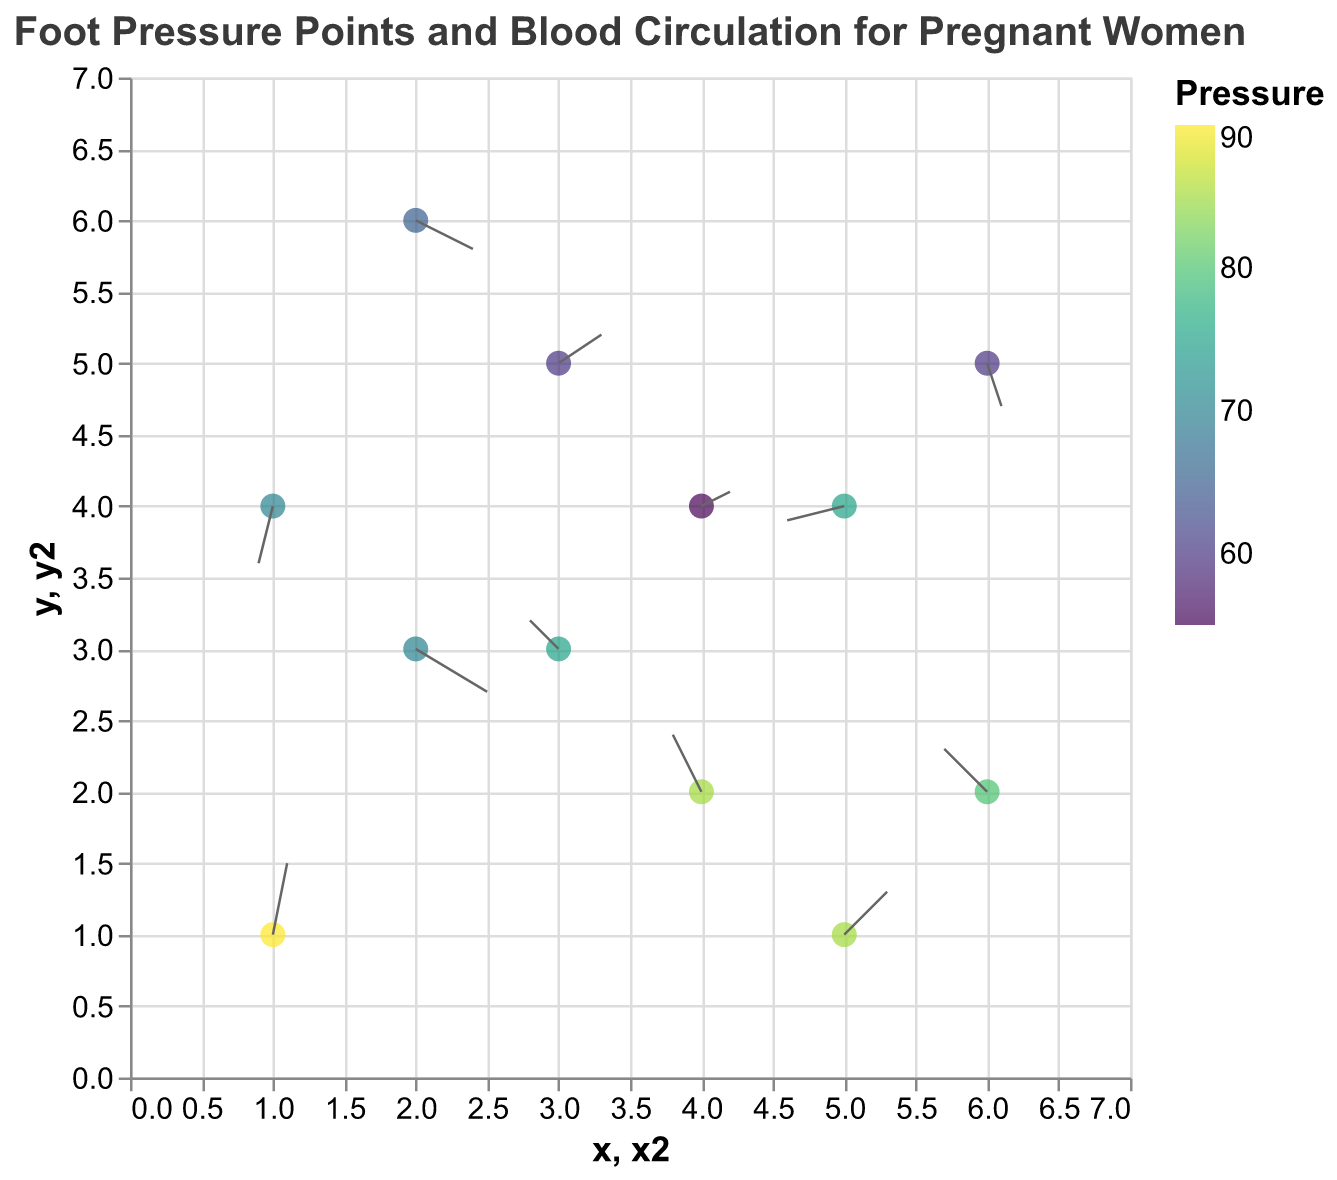What is the title of the figure? The title is usually located at the top of the plot and in this case, it reads "Foot Pressure Points and Blood Circulation for Pregnant Women".
Answer: Foot Pressure Points and Blood Circulation for Pregnant Women How many data points are represented in this figure? You can count the number of points or arrows in the quiver plot to find the total number of data points. By counting, there are 12 data points.
Answer: 12 Which data point has the highest pressure? By looking at the color legend associated with pressure and comparing individual points, the point at position (1,1) has the highest pressure value, which is 90.
Answer: (1,1) What is the direction of blood flow at the point located at (2,3)? Look for the arrow originating from (2,3). It points right and slightly downwards, indicating a direction (0.5, -0.3).
Answer: Right and slightly downward Among the data points with a pressure greater than 80, which has the largest magnitude of blood flow vector (u,v)? First, identify points with pressure > 80: (4,2), (5,1), and (1,1). Calculate the magnitude for each: sqrt((-0.2)^2 + (0.4)^2) = 0.447, sqrt((0.3)^2 + (0.3)^2) = 0.424, sqrt((0.1)^2 + (0.5)^2) = 0.509. The point (1,1) has the largest magnitude.
Answer: (1,1) What is the average pressure value for the data points? Sum all pressure values: 70 + 85 + 60 + 75 + 90 + 80 + 65 + 55 + 70 + 85 + 75 + 60 = 870. Divide by the number of points: 870 / 12.
Answer: 72.5 Which data point shows the strongest upward blood flow direction? The strongest upward direction would have the highest positive v value. The point at (1,1) has a v value of 0.5, which is the highest positive value in the dataset.
Answer: (1,1) Compare the blood circulation vector at (4,2) and (6,2). Which has a stronger rightward component? Rightward component is determined by the value of u. At (4,2), u is -0.2 (leftward) and at (6,2) u is -0.3 (leftward). Hence, (4,2) is less leftward compared to (6,2).
Answer: (4,2) Which region (quadrant) of the plot has the most data points? Visually inspect the plot and count data points in each quadrant. The lower left quadrant (x < 3.5, y < 3.5) has 4 data points, the lower right quadrant (x >= 3.5, y < 3.5) has 4 points, the upper left quadrant (x < 3.5, y >= 3.5) has 2 points, and the upper right quadrant (x >= 3.5, y >= 3.5) has 2 points.
Answer: Lower left and lower right quadrants What is the resultant vector direction for the point at (5,4)? The vector provided is (-0.4, -0.1). This means the direction is leftward and slightly downward.
Answer: Leftward and slightly downward 